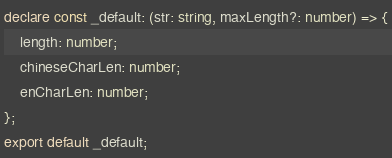Convert code to text. <code><loc_0><loc_0><loc_500><loc_500><_TypeScript_>declare const _default: (str: string, maxLength?: number) => {
    length: number;
    chineseCharLen: number;
    enCharLen: number;
};
export default _default;
</code> 